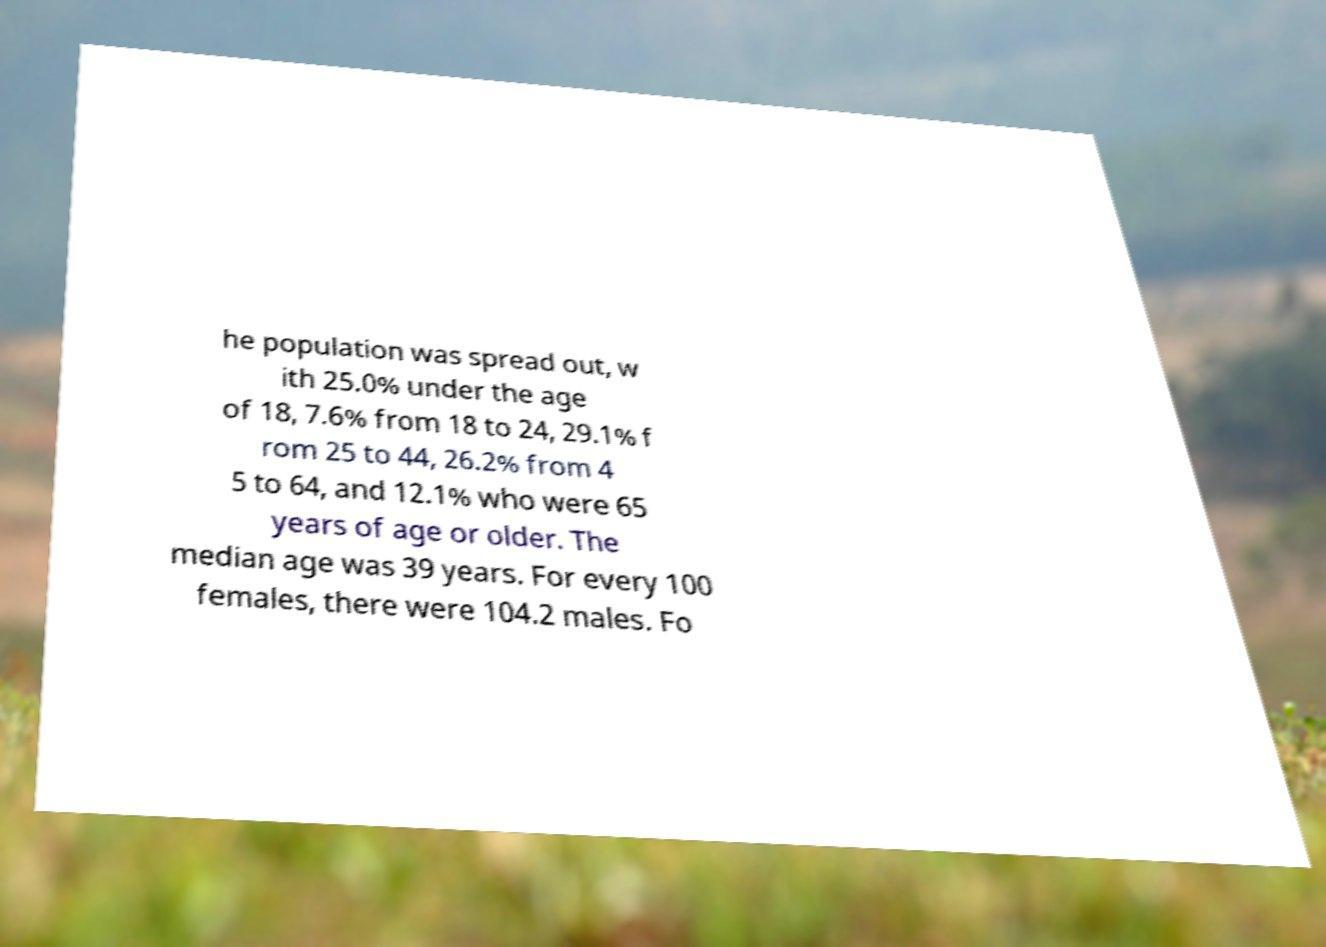Could you assist in decoding the text presented in this image and type it out clearly? he population was spread out, w ith 25.0% under the age of 18, 7.6% from 18 to 24, 29.1% f rom 25 to 44, 26.2% from 4 5 to 64, and 12.1% who were 65 years of age or older. The median age was 39 years. For every 100 females, there were 104.2 males. Fo 